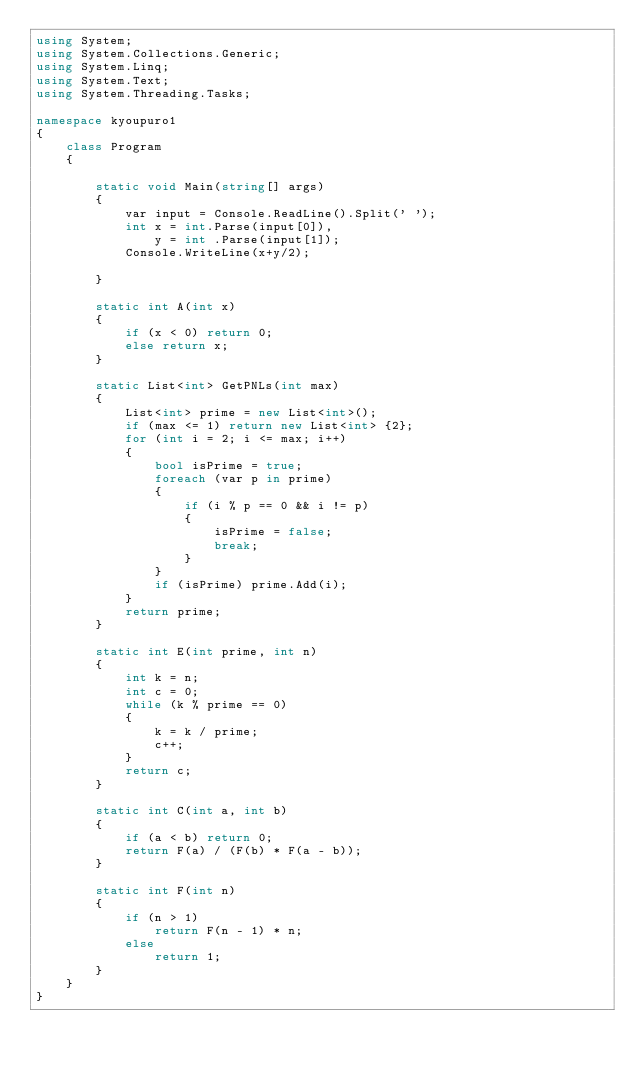<code> <loc_0><loc_0><loc_500><loc_500><_C#_>using System;
using System.Collections.Generic;
using System.Linq;
using System.Text;
using System.Threading.Tasks;

namespace kyoupuro1
{
    class Program
    {

        static void Main(string[] args)
        {
            var input = Console.ReadLine().Split(' '); 
            int x = int.Parse(input[0]),
                y = int .Parse(input[1]);
            Console.WriteLine(x+y/2);
            
        }

        static int A(int x)
        {
            if (x < 0) return 0;
            else return x;
        }

        static List<int> GetPNLs(int max)
        {
            List<int> prime = new List<int>();
            if (max <= 1) return new List<int> {2};
            for (int i = 2; i <= max; i++)
            {
                bool isPrime = true;
                foreach (var p in prime)
                {
                    if (i % p == 0 && i != p)
                    {
                        isPrime = false;
                        break;
                    }
                }
                if (isPrime) prime.Add(i);
            }
            return prime;
        }

        static int E(int prime, int n)
        {
            int k = n;
            int c = 0;
            while (k % prime == 0)
            {
                k = k / prime;
                c++;
            }
            return c;
        }

        static int C(int a, int b)
        {
            if (a < b) return 0;
            return F(a) / (F(b) * F(a - b));
        }

        static int F(int n)
        {
            if (n > 1)
                return F(n - 1) * n;
            else
                return 1;
        }
    }
}
</code> 